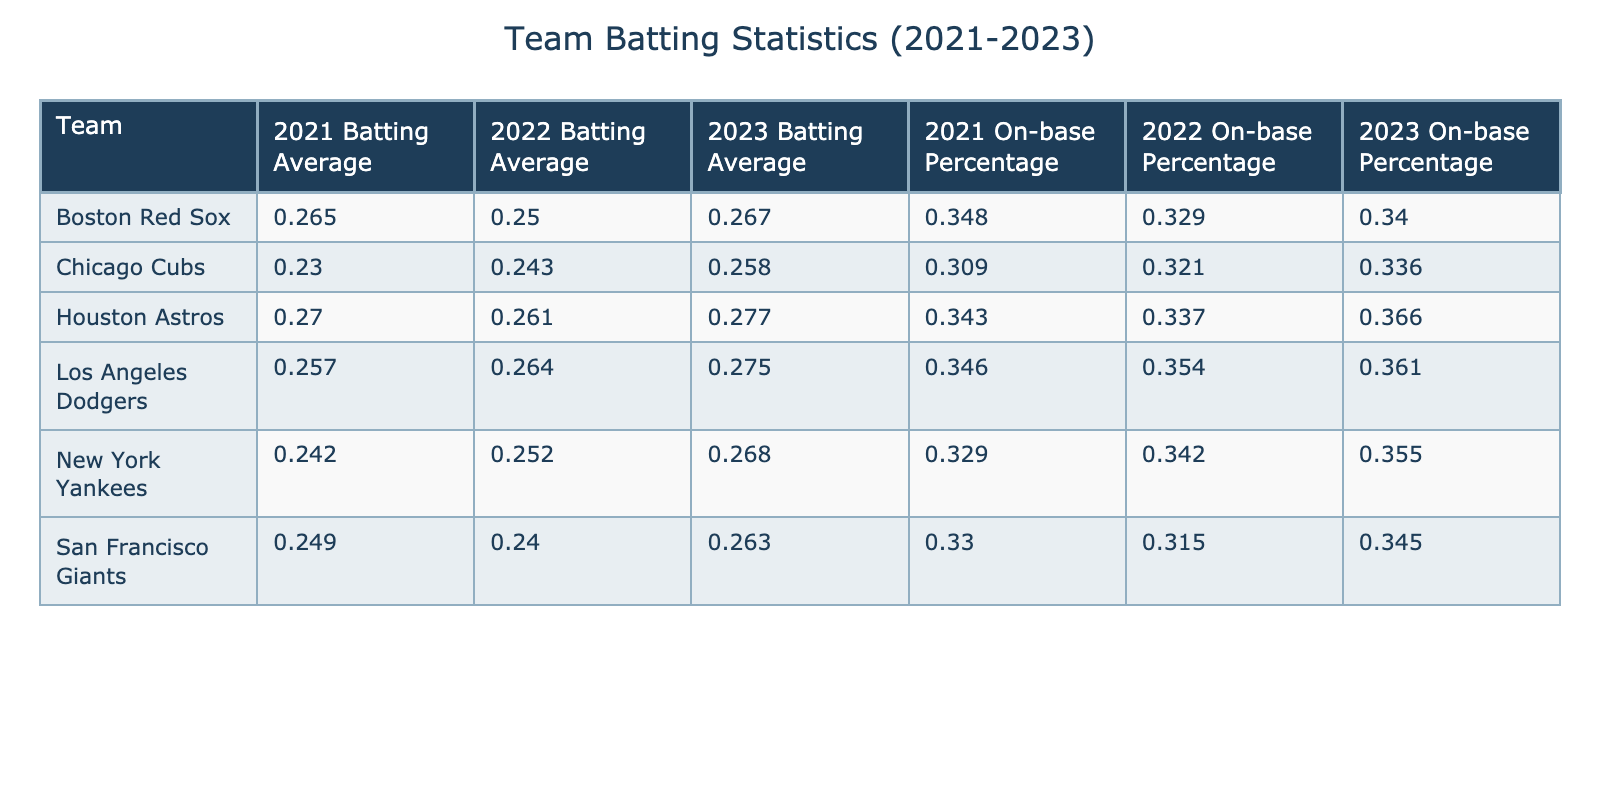What was the batting average of the New York Yankees in 2023? The table shows the batting averages for each team in each season. For the New York Yankees in 2023, the batting average listed is 0.268.
Answer: 0.268 Which team had the highest batting average in 2021? By comparing the batting averages of all teams in 2021, the Houston Astros had the highest average at 0.270.
Answer: Houston Astros What is the difference in batting averages between the Los Angeles Dodgers in 2022 and 2023? The batting average for the Los Angeles Dodgers in 2022 is 0.264, and in 2023 it is 0.275. Subtracting these values gives a difference of 0.275 - 0.264 = 0.011.
Answer: 0.011 Which team improved their batting average the most from 2021 to 2023? First, we find the batting averages for each team in 2021 and 2023 and calculate the differences. The biggest improvement is from the Houston Astros, moving from 0.270 to 0.277, a change of 0.007.
Answer: Houston Astros True or False: The Boston Red Sox had a higher on-base percentage than the Chicago Cubs in 2023. The on-base percentage for the Boston Red Sox in 2023 is 0.340, while for the Chicago Cubs, it is 0.336. Since 0.340 is greater than 0.336, the statement is true.
Answer: True What was the average on-base percentage for the San Francisco Giants over the three seasons? We sum the on-base percentages for the San Francisco Giants across all three seasons: 0.330 + 0.315 + 0.345 = 0.990. Then we divide this sum by 3 to find the average: 0.990 / 3 = 0.330.
Answer: 0.330 How many teams had a batting average above 0.260 in 2023? We inspect the batting averages reported for 2023 and count the teams that had averages greater than 0.260. They are the New York Yankees (0.268), Los Angeles Dodgers (0.275), Houston Astros (0.277), and Boston Red Sox (0.267), totaling four teams.
Answer: 4 Which team had the lowest on-base percentage across all seasons? By reviewing the on-base percentages for each team across the three seasons, the Chicago Cubs had the lowest recorded at 0.309 in 2021.
Answer: Chicago Cubs What is the average change in batting average for the New York Yankees from 2021 to 2023? First, we find the batting averages for the New York Yankees: 0.242 in 2021 and 0.268 in 2023. The change is 0.268 - 0.242 = 0.026. The average for the two seasons is (0.242 + 0.268) / 2 = 0.255. Hence, the average change is 0.026 over 2 seasons.
Answer: 0.026 How do the Houston Astros' on-base percentages from 2022 to 2023 compare, and which had more? The on-base percentage for the Houston Astros in 2022 is 0.337 and 0.366 in 2023. Since 0.366 is greater than 0.337, the 2023 figure is higher.
Answer: 2023 is higher 